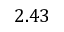Convert formula to latex. <formula><loc_0><loc_0><loc_500><loc_500>2 . 4 3</formula> 